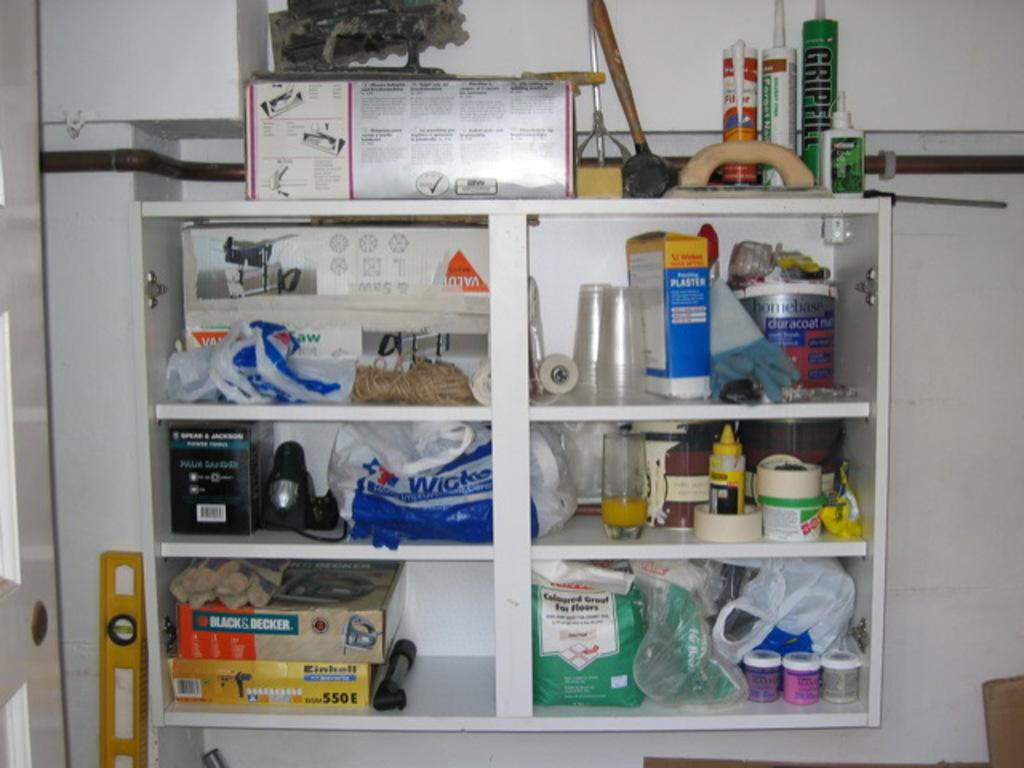<image>
Summarize the visual content of the image. Some Black and Decker products sit on a shelf. 